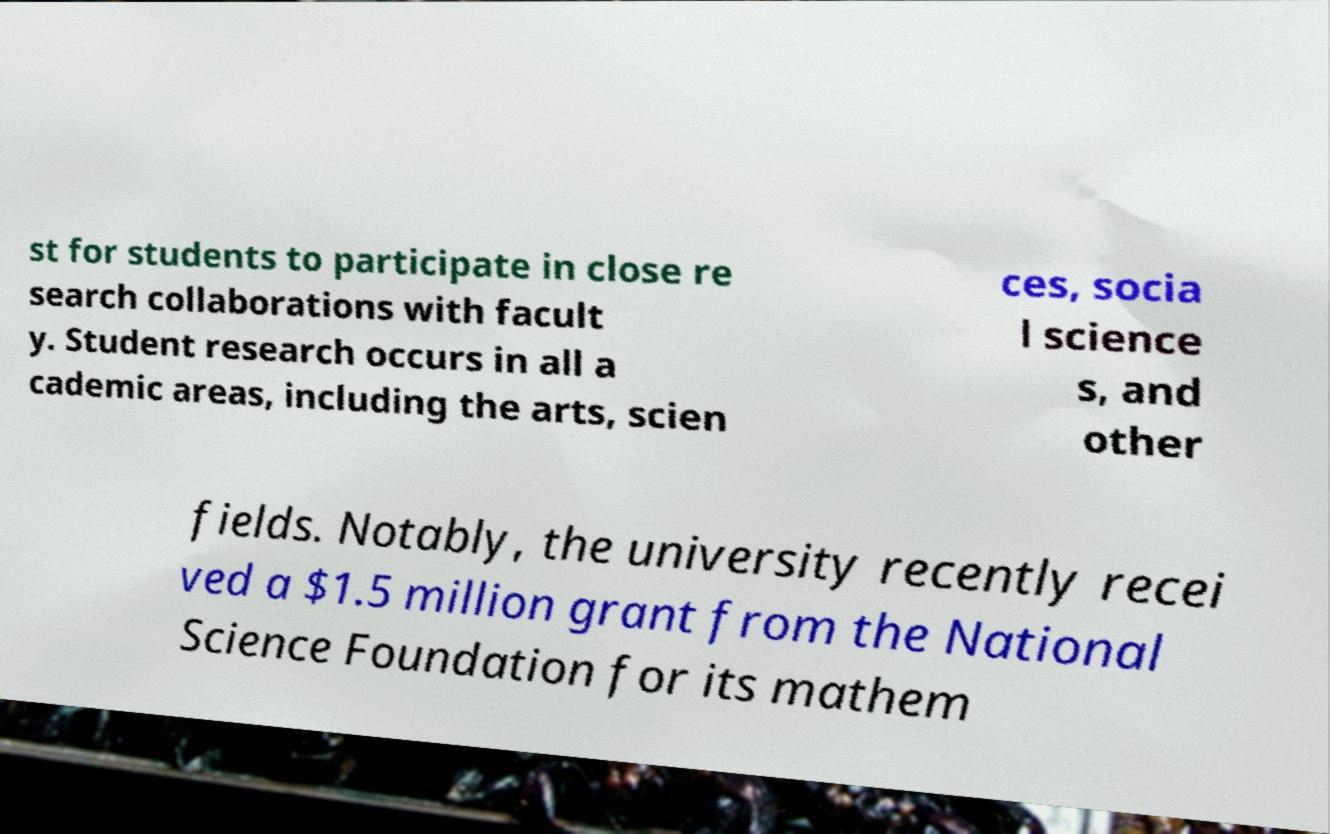Can you read and provide the text displayed in the image?This photo seems to have some interesting text. Can you extract and type it out for me? st for students to participate in close re search collaborations with facult y. Student research occurs in all a cademic areas, including the arts, scien ces, socia l science s, and other fields. Notably, the university recently recei ved a $1.5 million grant from the National Science Foundation for its mathem 